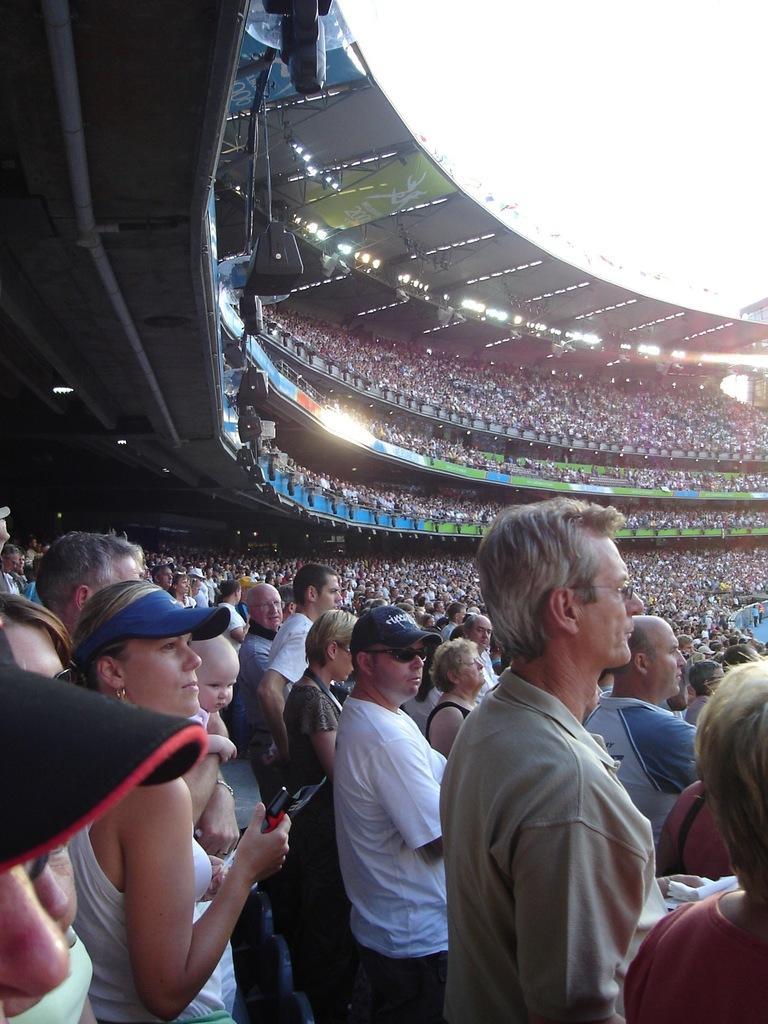How would you summarize this image in a sentence or two? In the foreground of the image we can see some persons are standing. In the middle of the image we can see crowd sitting on the chairs and some lights. On the top of the image we can see the sky. 